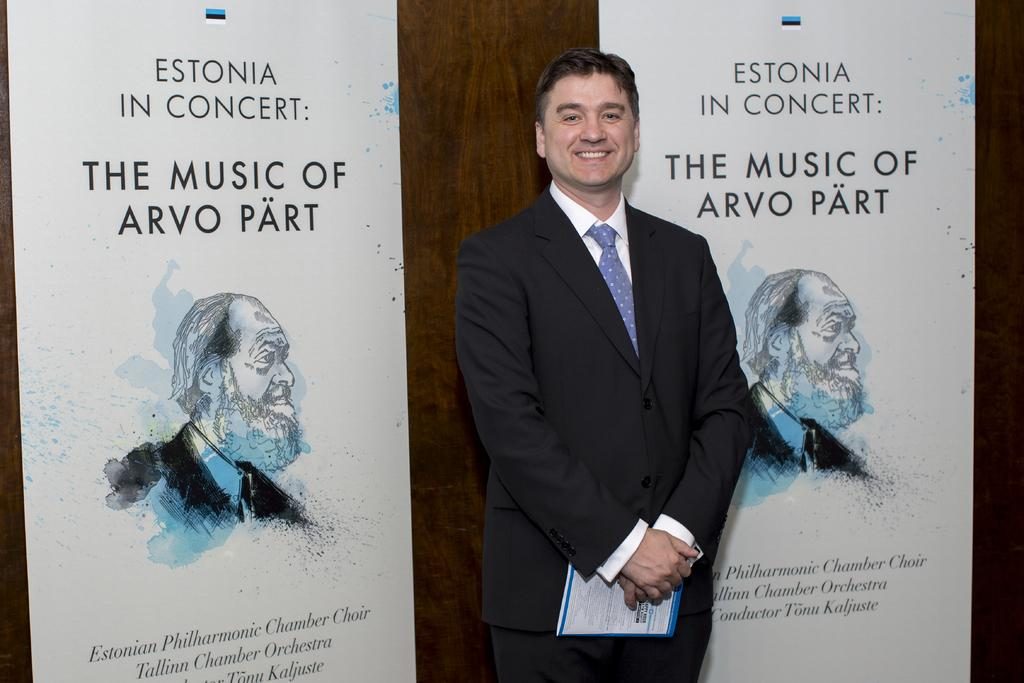What is the man in the image doing? The man is standing in the image and posing for a photo. How is the man feeling in the image? The man is laughing, which suggests he is happy or amused. What can be seen in the background of the image? There are two similar posters in the background. What features do the posters have? The posters have some text and an image of a person. Can you see any circles or stems in the image? There are no circles or stems present in the image. Is the man standing near the seashore in the image? The provided facts do not mention any seashore or water in the image. 